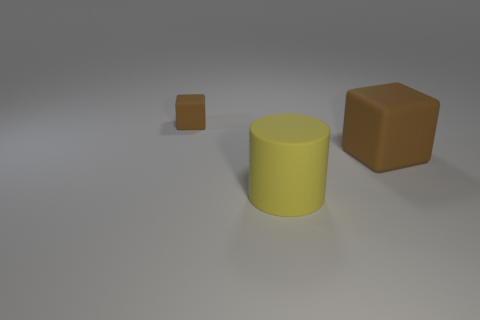Add 2 tiny brown rubber things. How many objects exist? 5 Subtract all cylinders. How many objects are left? 2 Add 3 large yellow matte things. How many large yellow matte things are left? 4 Add 3 things. How many things exist? 6 Subtract 0 red cylinders. How many objects are left? 3 Subtract all red cylinders. Subtract all cyan spheres. How many cylinders are left? 1 Subtract all big yellow rubber cylinders. Subtract all tiny gray cylinders. How many objects are left? 2 